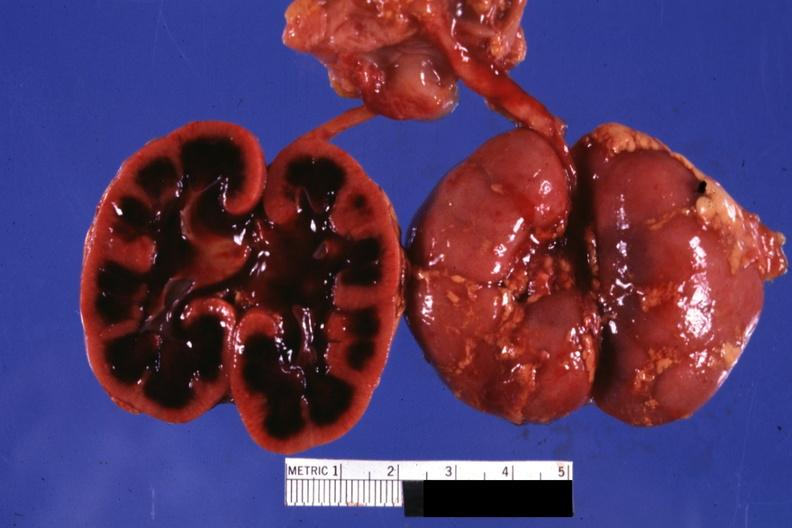s kidney present?
Answer the question using a single word or phrase. Yes 